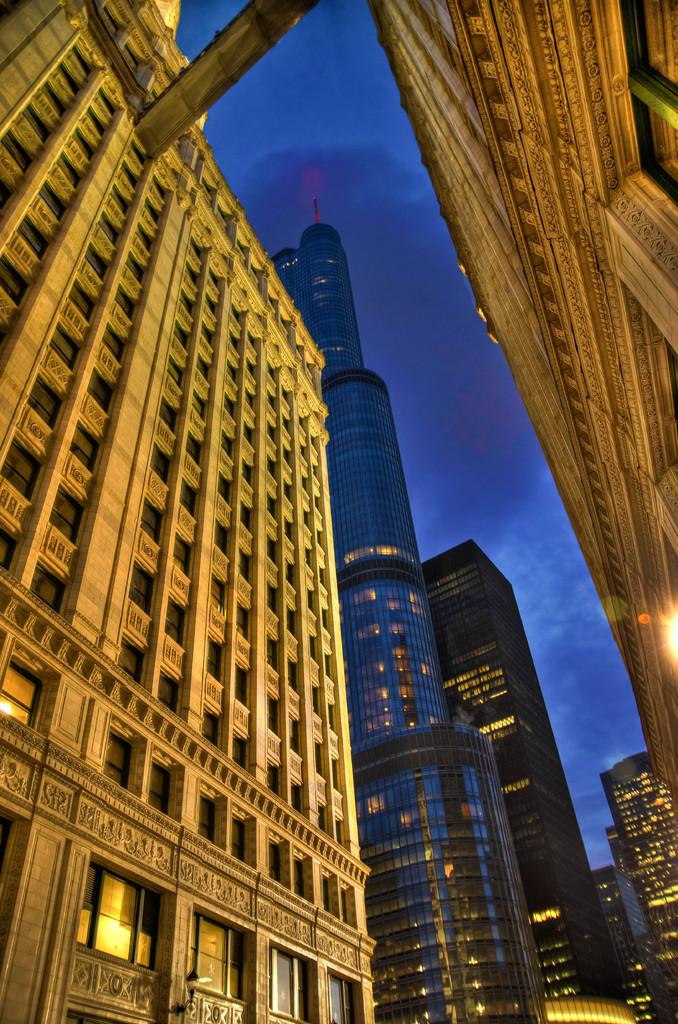What type of structures are visible in the image? There are buildings in the image. What is the condition of the sky in the image? The sky is cloudy in the image. What type of texture can be seen on the sofa in the image? There is no sofa present in the image. What mode of transport can be seen in the image? There is no mode of transport visible in the image; only buildings and a cloudy sky are present. 